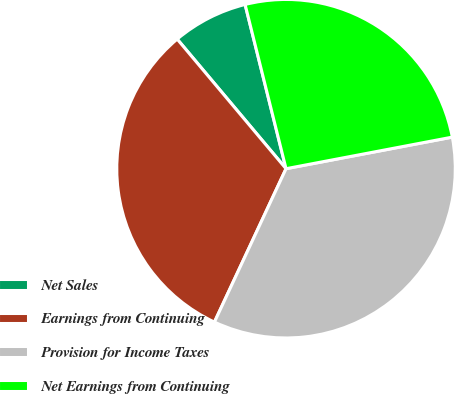<chart> <loc_0><loc_0><loc_500><loc_500><pie_chart><fcel>Net Sales<fcel>Earnings from Continuing<fcel>Provision for Income Taxes<fcel>Net Earnings from Continuing<nl><fcel>7.23%<fcel>31.93%<fcel>34.94%<fcel>25.9%<nl></chart> 